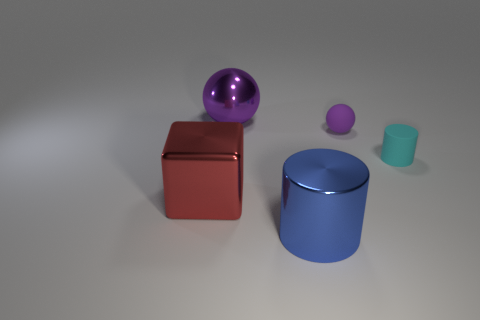Does the cylinder behind the shiny cube have the same size as the rubber sphere?
Make the answer very short. Yes. What is the shape of the big object that is behind the small matte cylinder in front of the purple object left of the large blue object?
Provide a short and direct response. Sphere. What number of objects are either big cylinders or big shiny things behind the cyan rubber cylinder?
Your answer should be very brief. 2. There is a sphere that is in front of the big purple ball; how big is it?
Keep it short and to the point. Small. What is the shape of the large shiny object that is the same color as the matte ball?
Provide a short and direct response. Sphere. Is the cyan object made of the same material as the large thing that is behind the cyan cylinder?
Your answer should be compact. No. How many purple things are behind the purple thing on the left side of the object in front of the big block?
Your answer should be compact. 0. How many green objects are either metal cylinders or small matte things?
Provide a succinct answer. 0. What shape is the purple object that is to the right of the large blue cylinder?
Offer a very short reply. Sphere. What is the color of the cylinder that is the same size as the metallic block?
Your answer should be very brief. Blue. 